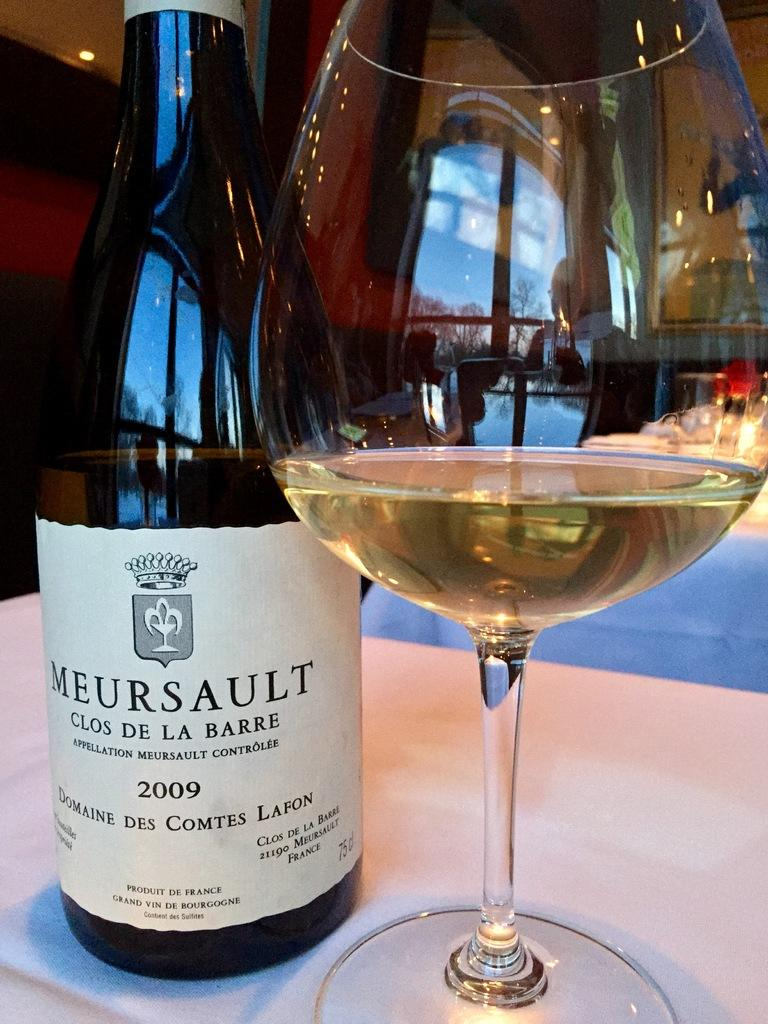What is present on the table in the image? There is a bottle and a glass on the table in the image. What is the purpose of the bottle and the glass? The bottle and the glass are likely used for holding or serving a beverage. Can you describe the location of the bottle and the glass? Both the bottle and the glass are on a table in the image. What type of whip can be seen in the image? There is no whip present in the image; it only features a bottle and a glass on a table. 